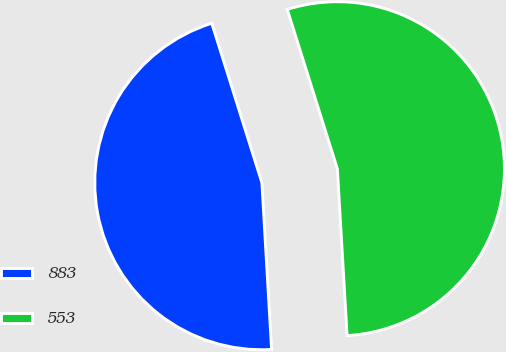Convert chart. <chart><loc_0><loc_0><loc_500><loc_500><pie_chart><fcel>883<fcel>553<nl><fcel>46.08%<fcel>53.92%<nl></chart> 